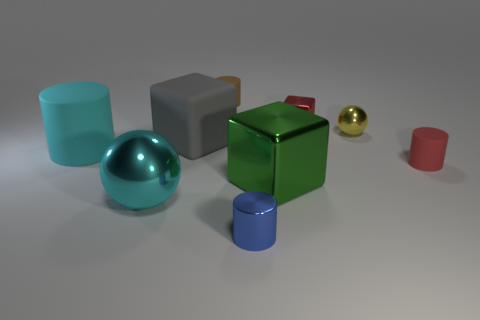Does the metallic object on the right side of the tiny metal block have the same shape as the gray object?
Provide a succinct answer. No. There is a green object that is the same shape as the red metallic thing; what is it made of?
Keep it short and to the point. Metal. How many gray rubber cubes have the same size as the yellow metal object?
Ensure brevity in your answer.  0. There is a small cylinder that is both to the left of the small red cylinder and behind the green metal thing; what color is it?
Provide a short and direct response. Brown. Are there fewer yellow rubber things than rubber objects?
Keep it short and to the point. Yes. There is a matte cube; is its color the same as the metal ball left of the small brown cylinder?
Provide a succinct answer. No. Are there the same number of big cyan matte cylinders in front of the blue metallic cylinder and cyan balls to the right of the red metal block?
Keep it short and to the point. Yes. What number of big cyan shiny things are the same shape as the yellow object?
Your answer should be very brief. 1. Is there a large red matte object?
Your answer should be very brief. No. Is the material of the small blue cylinder the same as the cylinder behind the small yellow metal ball?
Give a very brief answer. No. 